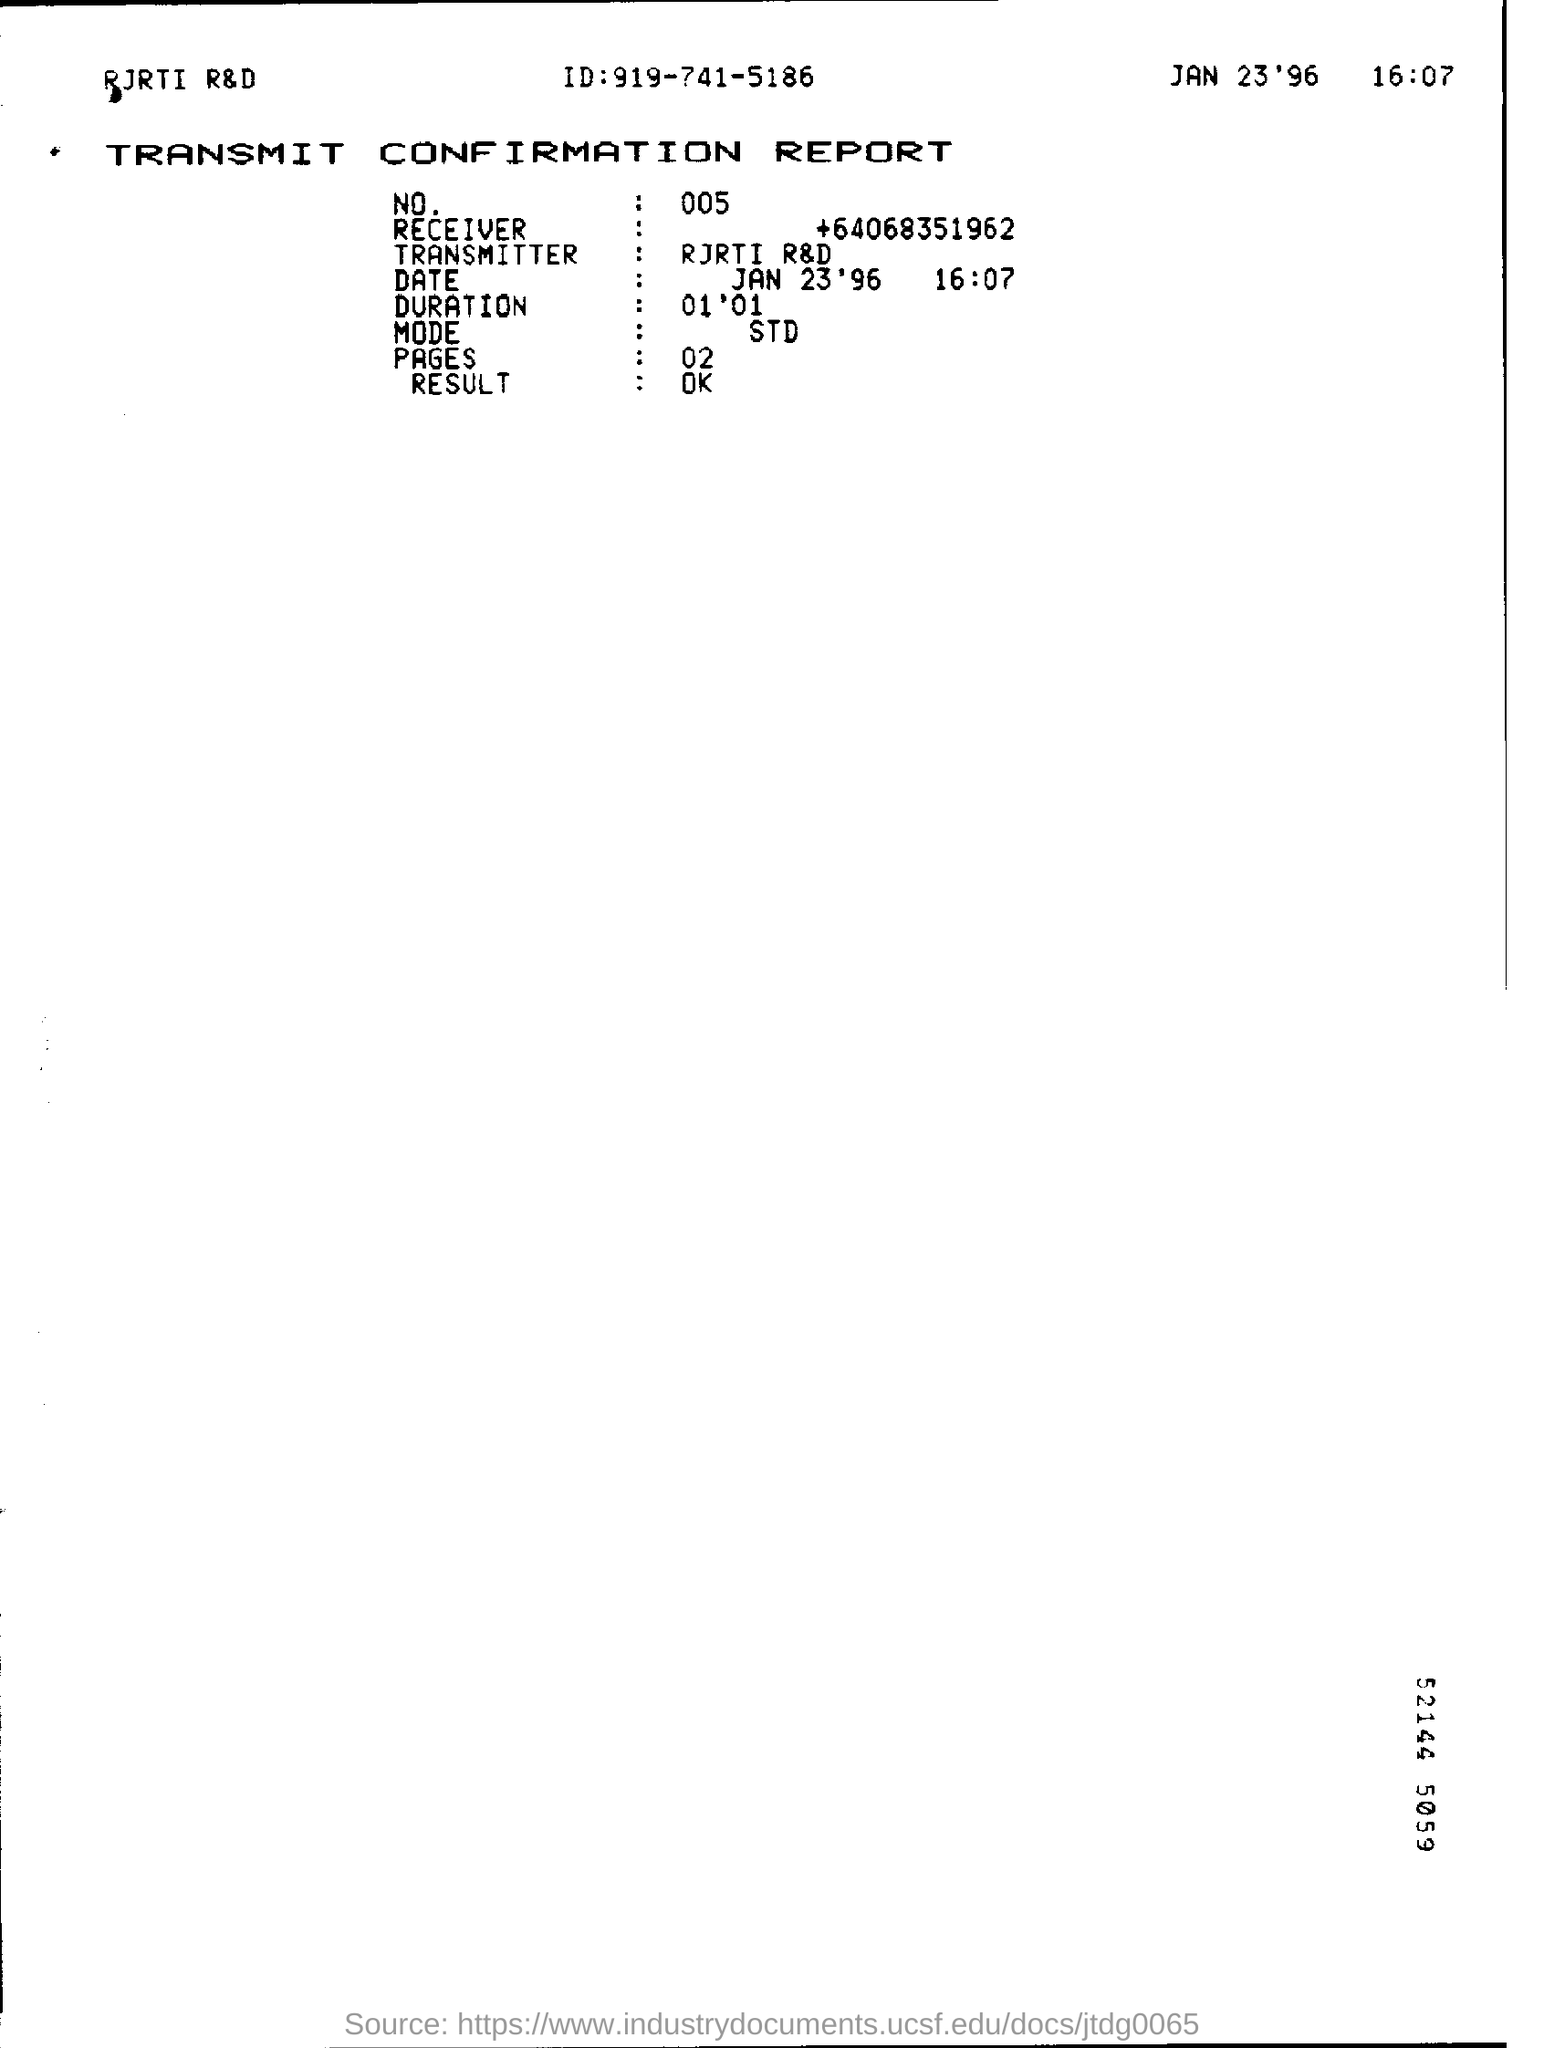Highlight a few significant elements in this photo. The mode is the value in a data set that is repeated the most number of times. Standard deviation is a measure of the spread or dispersion of a data set. The result is OK. The receiver is unknown and their phone number is +64 068 351 962. The duration is 01, which means that it starts on the first day of the year and ends on the following day. The Transmitter is RJRTI R&D. 